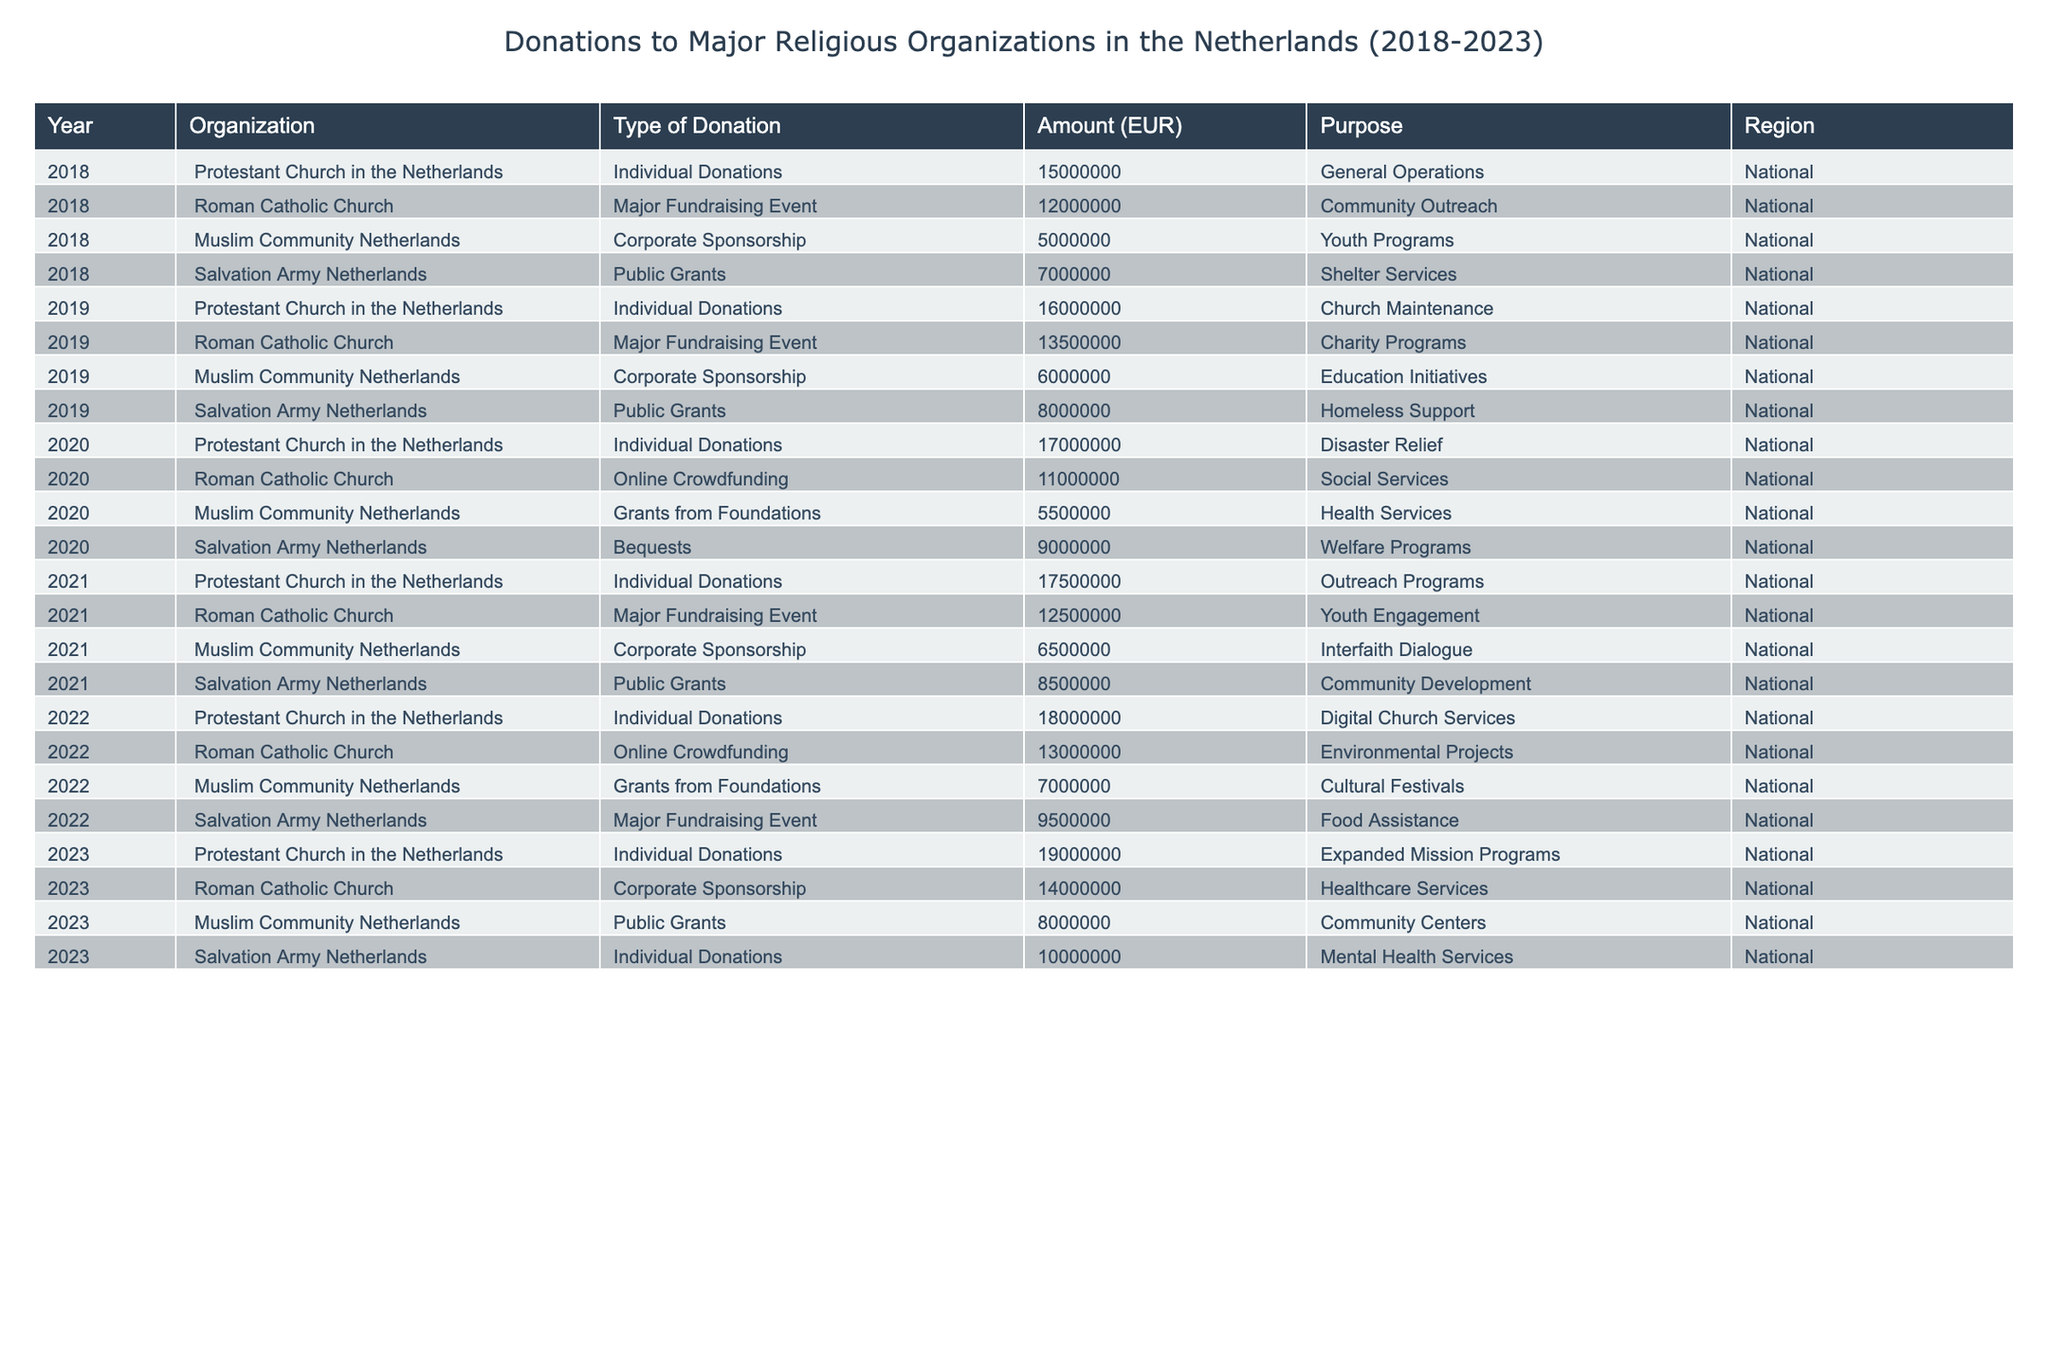What was the total amount of individual donations received by the Protestant Church in the Netherlands from 2018 to 2023? To find the total individual donations for the Protestant Church in the Netherlands, we sum the amounts from each year: 15,000,000 (2018) + 16,000,000 (2019) + 17,000,000 (2020) + 17,500,000 (2021) + 18,000,000 (2022) + 19,000,000 (2023) = 102,500,000
Answer: 102500000 Which organization received the least amount of donations in 2019? Looking at the 2019 row for each organization: Protestant Church (16,000,000), Roman Catholic Church (13,500,000), Muslim Community (6,000,000), Salvation Army (8,000,000). The Muslim Community received 6,000,000, which is the least.
Answer: Muslim Community Netherlands In 2020, what type of donation did the Roman Catholic Church receive? We can see from the table that in 2020, the Roman Catholic Church received donations from online crowdfunding.
Answer: Online Crowdfunding What was the percentage increase in total donations from the Salvation Army Netherlands from 2021 to 2022? First, the total for the Salvation Army in 2021 is 8,500,000, and in 2022, it is 9,500,000. The difference is 9,500,000 - 8,500,000 = 1,000,000. To find the percentage increase, use the formula (1,000,000 / 8,500,000) * 100 = 11.76%.
Answer: 11.76% Did the Protestant Church in the Netherlands receive the highest amount of donations in 2023 compared to other organizations? In 2023, the Protestant Church received 19,000,000, Roman Catholic Church 14,000,000, Muslim Community 8,000,000, and Salvation Army 10,000,000. Hence, 19,000,000 is the highest amount.
Answer: Yes What was the total amount of donations received by the Roman Catholic Church between 2018 and 2023? To find the total, sum the contributions over the years: 12,000,000 (2018) + 13,500,000 (2019) + 11,000,000 (2020) + 12,500,000 (2021) + 13,000,000 (2022) + 14,000,000 (2023) = 76,000,000.
Answer: 76000000 What is the average donation amount received by the Muslim Community Netherlands over the listed years? The amounts received by the Muslim Community are 5,000,000 (2018), 6,000,000 (2019), 5,500,000 (2020), 6,500,000 (2021), 7,000,000 (2022), and 8,000,000 (2023). The total is 38,000,000, and since there are 6 years, the average is 38,000,000 / 6 = 6,333,333.33.
Answer: 6333333.33 What were the purposes of the donations received by the Salvation Army Netherlands in 2022? The table indicates that the purpose of the donations received by the Salvation Army in 2022 was food assistance.
Answer: Food Assistance How does the amount received by the Muslim Community Netherlands in 2021 compare to the amount received in 2023? The Muslim Community received 6,500,000 in 2021 and 8,000,000 in 2023. Since 8,000,000 is greater than 6,500,000, the 2023 amount is higher.
Answer: Higher What was the trend in individual donations to the Protestant Church in the Netherlands from 2018 to 2023? Analyzing the amounts: 15,000,000 (2018), 16,000,000 (2019), 17,000,000 (2020), 17,500,000 (2021), 18,000,000 (2022), and 19,000,000 (2023) shows a consistent increase each year.
Answer: Consistent increase 